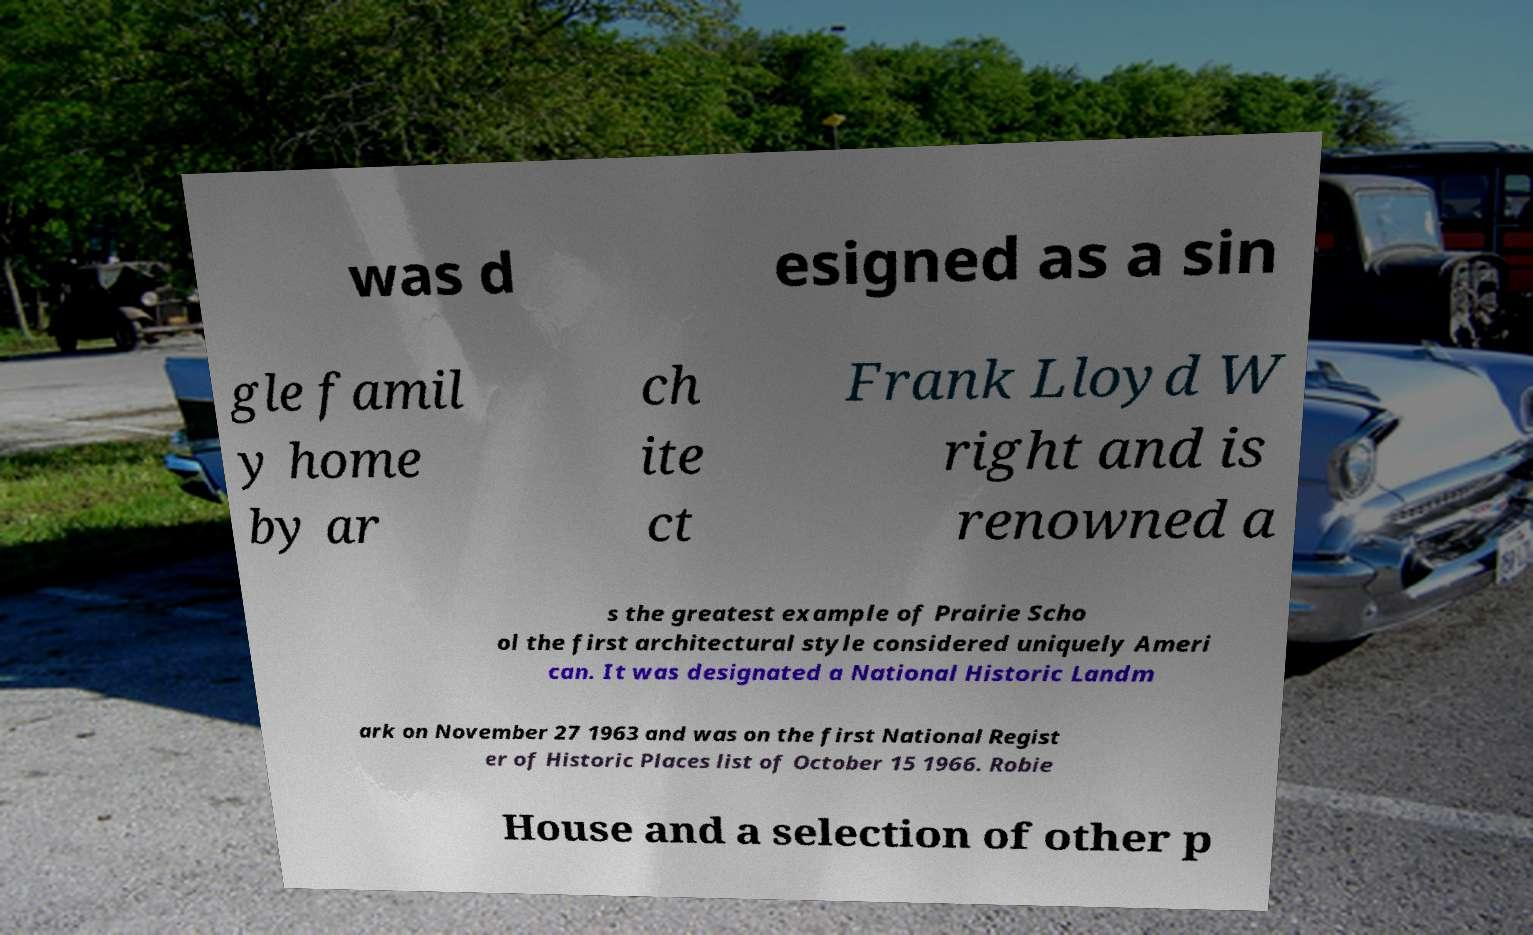What messages or text are displayed in this image? I need them in a readable, typed format. was d esigned as a sin gle famil y home by ar ch ite ct Frank Lloyd W right and is renowned a s the greatest example of Prairie Scho ol the first architectural style considered uniquely Ameri can. It was designated a National Historic Landm ark on November 27 1963 and was on the first National Regist er of Historic Places list of October 15 1966. Robie House and a selection of other p 